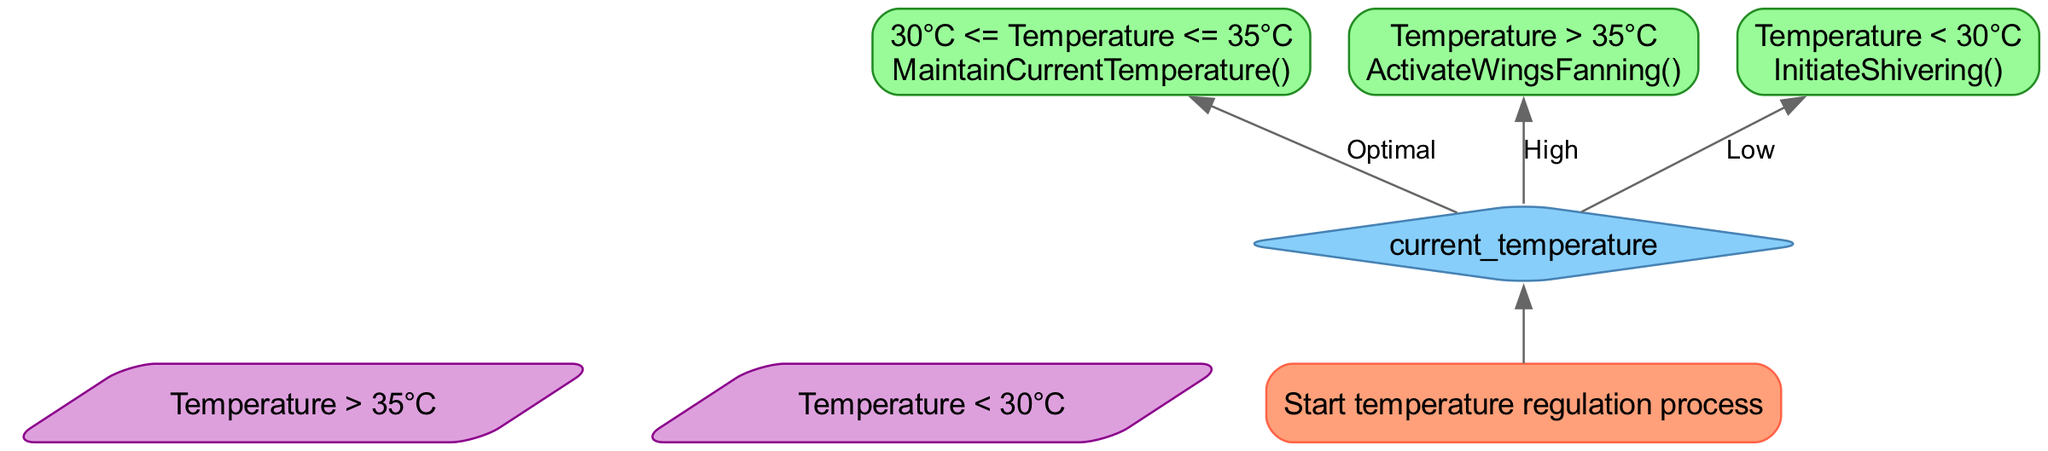what is the starting point of the flowchart? The starting point of the flowchart is the "regulate_temperature" node, which initiates the temperature regulation process.
Answer: regulate_temperature how many process nodes are present in the diagram? The diagram contains three process nodes: "optimum_temp", "cool_down", and "heat_up".
Answer: 3 what condition triggers the "cool_down" action? The "cool_down" action is triggered when the condition "Temperature > 35°C" is met.
Answer: Temperature > 35°C what action is performed when the temperature is within the optimum range? When the temperature is within the optimum range, the action performed is "MaintainCurrentTemperature()".
Answer: MaintainCurrentTemperature() what happens if the current temperature is less than 30°C? If the current temperature is less than 30°C, the next action is to "InitiateShivering()".
Answer: InitiateShivering() if the temperature is high, which node does the flow go to after checking temperature? If the temperature is high, the flow goes to the "cool_down" node after checking the temperature.
Answer: cool_down how does the "check_temperature" node decide which action to take? The "check_temperature" node evaluates the current temperature and directs the flow based on whether it is optimum, high, or low, leading to the respective nodes for each case.
Answer: Current temperature what color is used for decision nodes in the diagram? The decision nodes in the diagram are filled with the color "#87CEFA".
Answer: #87CEFA which process follows the decision of "Temperature < 30°C"? The process that follows the decision of "Temperature < 30°C" is "heat_up".
Answer: heat_up 